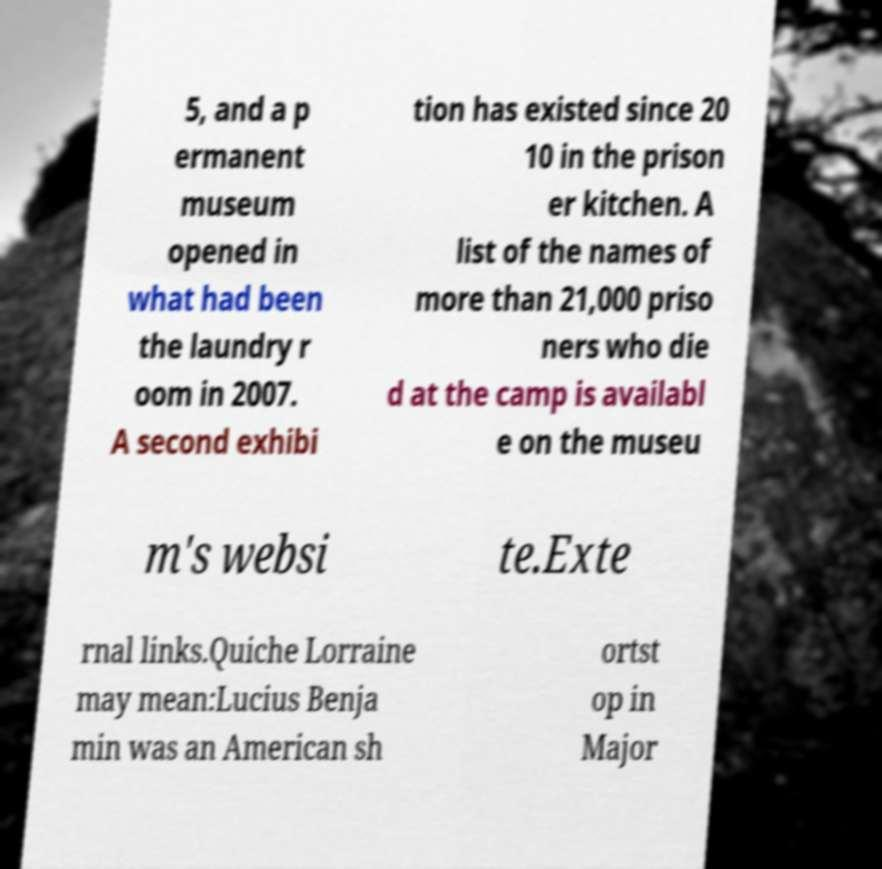What messages or text are displayed in this image? I need them in a readable, typed format. 5, and a p ermanent museum opened in what had been the laundry r oom in 2007. A second exhibi tion has existed since 20 10 in the prison er kitchen. A list of the names of more than 21,000 priso ners who die d at the camp is availabl e on the museu m's websi te.Exte rnal links.Quiche Lorraine may mean:Lucius Benja min was an American sh ortst op in Major 